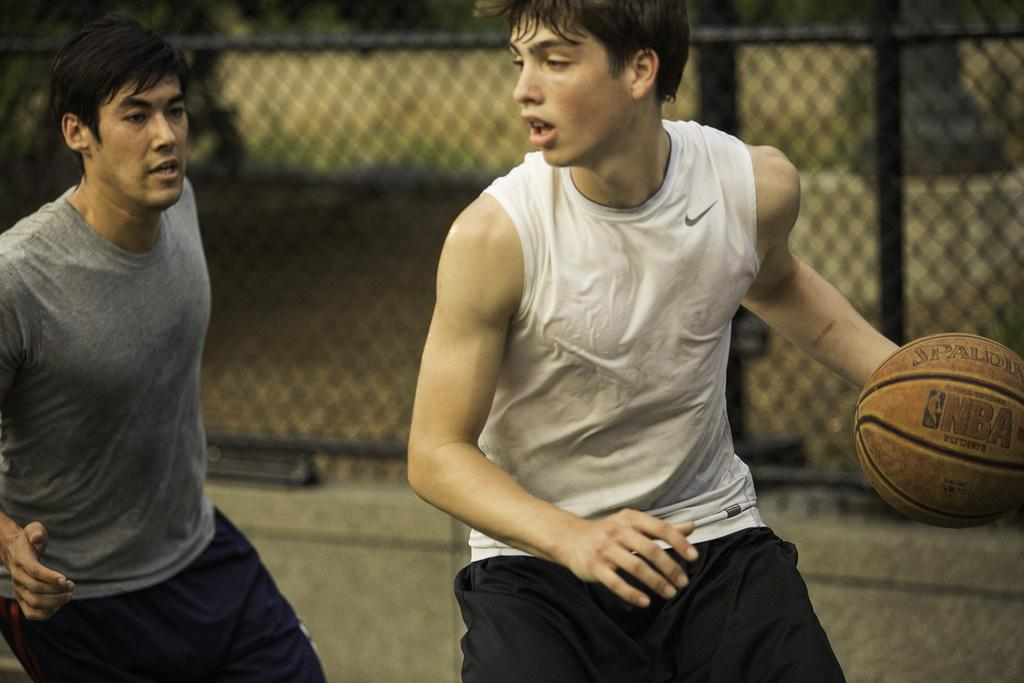How many people are in the image? There are two men in the image. What are the men doing in the image? The men are playing with a ball. What type of clothing are the men wearing? Both men are wearing t-shirts. What can be seen in the background of the image? There is a fence visible in the background of the image. What year is depicted in the image? The image does not depict a specific year; it is a photograph of two men playing with a ball. Can you see a bottle in the image? There is no bottle present in the image. 